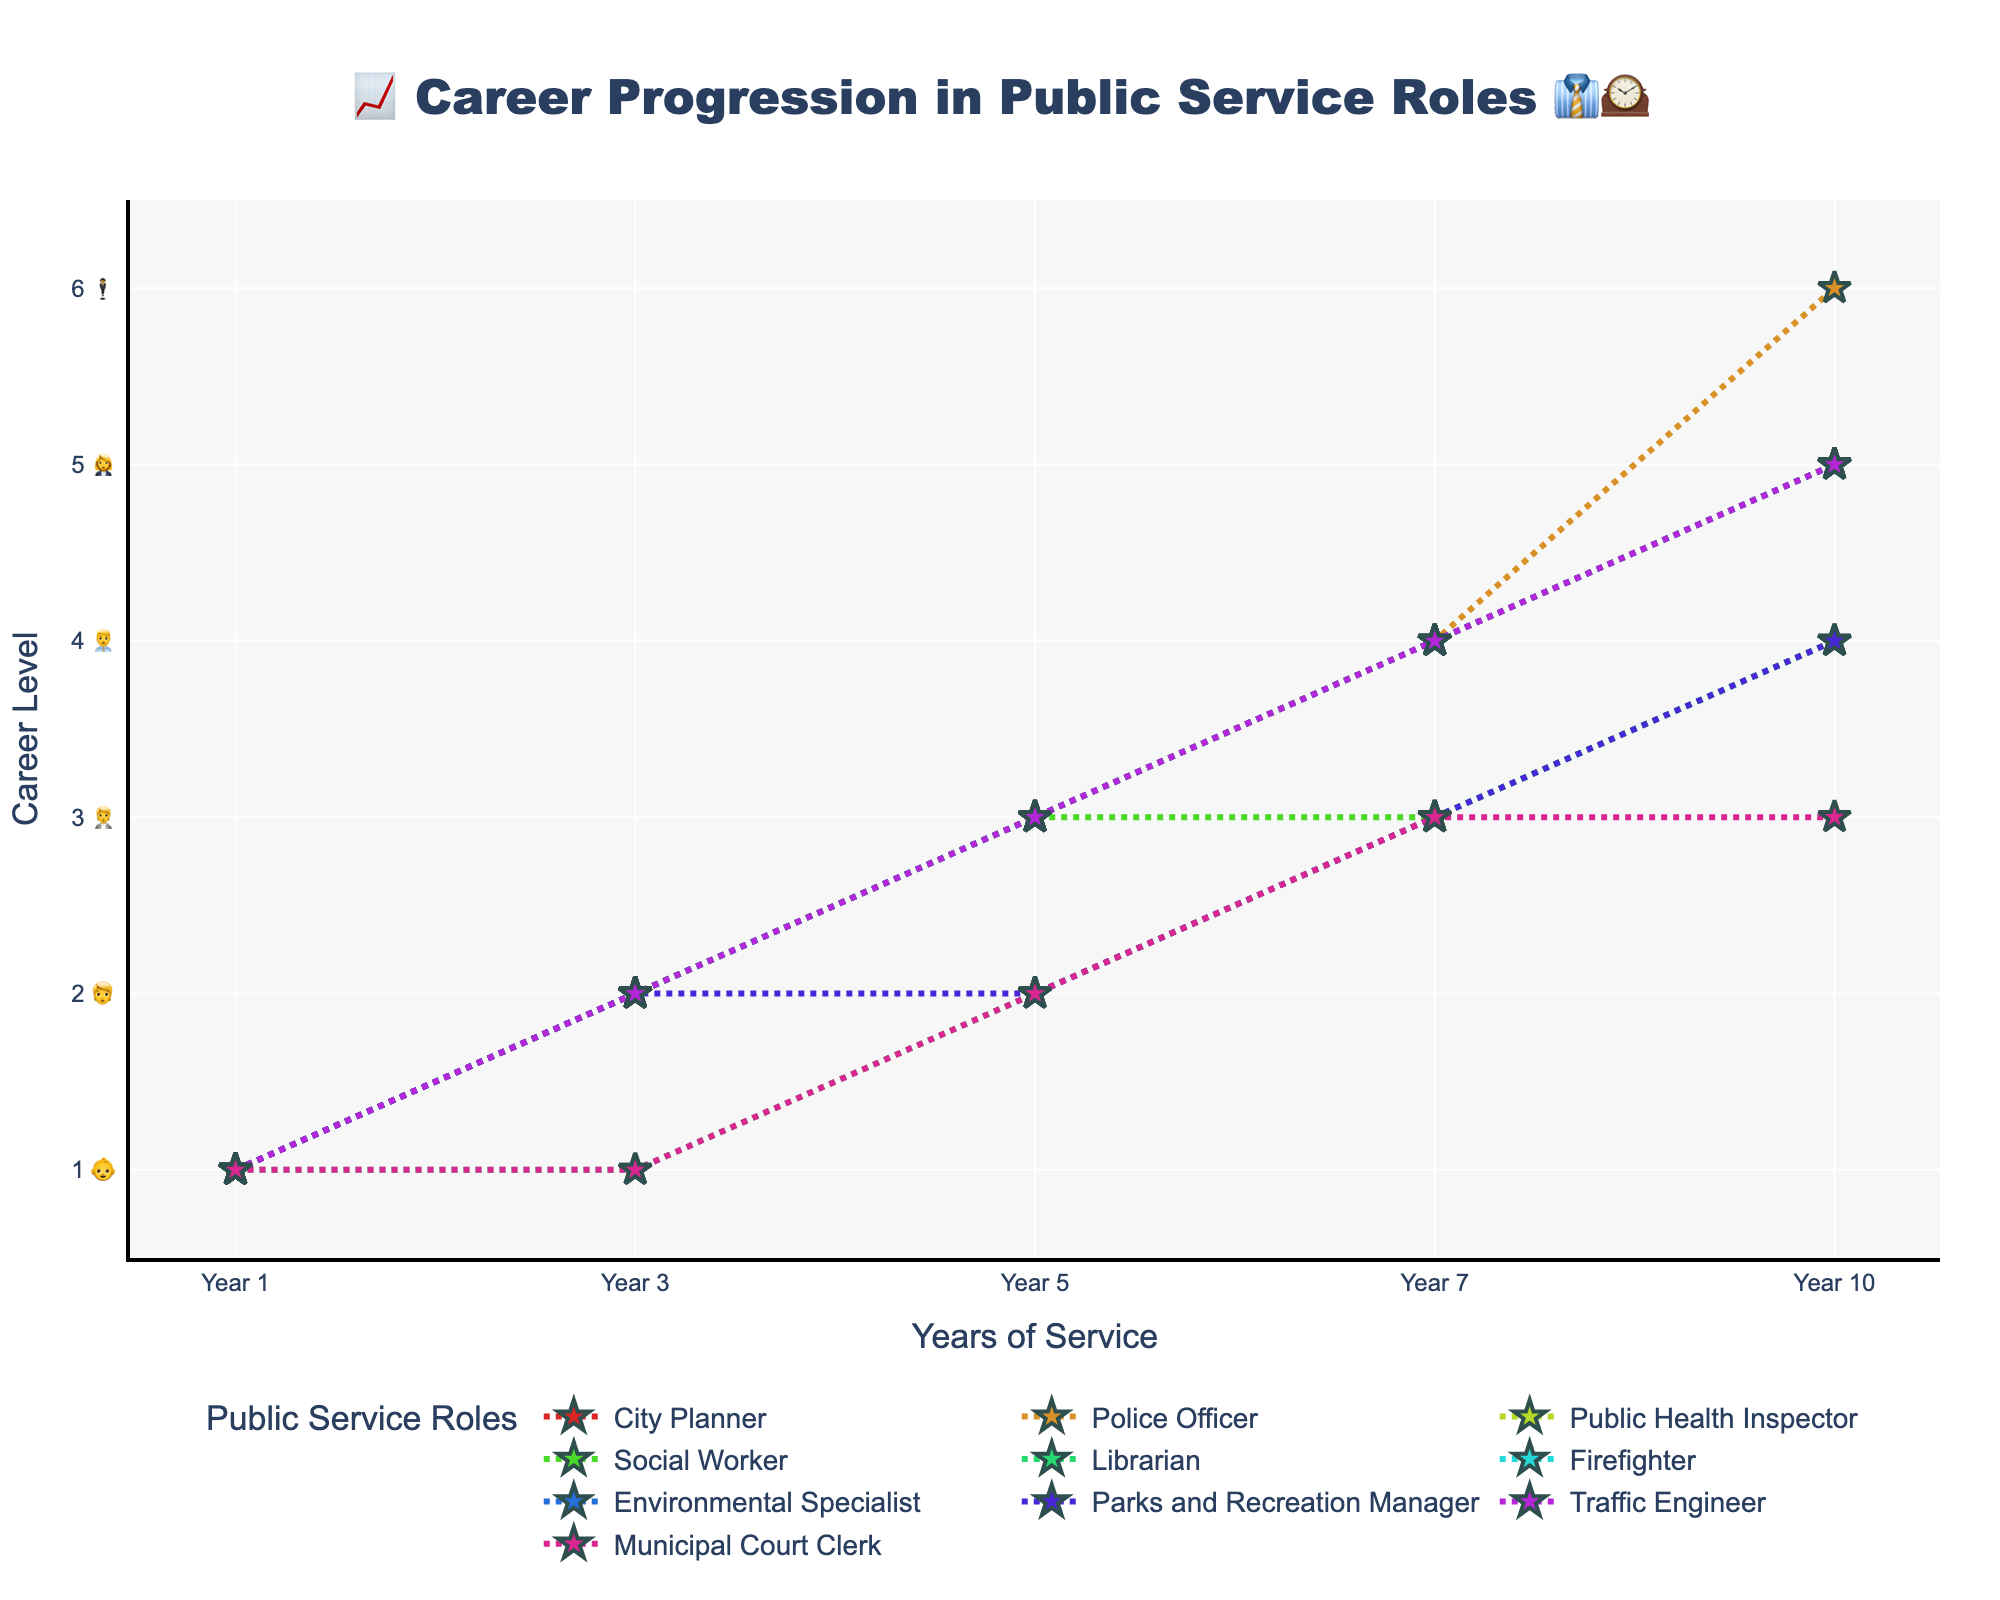What's the title of the chart? The title of the chart is positioned at the top center of the figure. It reads '📈 Career Progression in Public Service Roles 👔🕰️'. By looking at the chart, you can see this clearly.
Answer: 📈 Career Progression in Public Service Roles 👔🕰️ How many public service roles are depicted in the chart? Count the number of different lines in the chart, each representing a different public service role. There are lines with star-shaped markers representing each role.
Answer: 10 Which role shows the highest career level in Year 10? Look at the lines on the chart and find the one that reaches the highest position on the y-axis at Year 10. The Police Officer role reaches career level 6 at Year 10.
Answer: Police Officer What is the career level of Librarians in Year 7? Trace the line corresponding to Librarians and check its value at Year 7. This value represents the career level at that year.
Answer: 3 Which roles have the same career progression as City Planners over the 10-year period? Compare the lines for City Planners with other roles. Public Health Inspectors, Firefighters, Environmental Specialists, and Traffic Engineers follow the same progression pattern.
Answer: Public Health Inspector, Firefighter, Environmental Specialist, Traffic Engineer Between which years do Social Workers experience no career growth? Observe the line representing Social Workers and see where it remains flat. The line is flat between Year 5 and Year 7, indicating no growth during these years.
Answer: Year 5 and Year 7 What is the average career level of Public Health Inspectors across all years? Compute the average by summing up the career levels of Public Health Inspectors at each year (1+2+3+4+5) and divide by the number of years, which is 5. (1+2+3+4+5)/5 = 3
Answer: 3 Which role has the slowest career progression up to Year 5? Compare the career levels of all roles up to Year 5. Librarians have the slowest progression, reaching only level 2 by Year 5.
Answer: Librarian What is the difference in career level between Police Officers and Social Workers in Year 10? Look at the career levels of Police Officers and Social Workers in Year 10 and subtract the lower from the higher. Police Officer is at level 6, and Social Worker is at level 4. 6-4=2
Answer: 2 In which year do Parks and Recreation Managers first experience a career level decrease? Identify the point where the Parks and Recreation Managers’ line dips or stays the same instead of increasing. The decrease happens between Year 3 and Year 5 as the level remains 2.
Answer: Year 3 